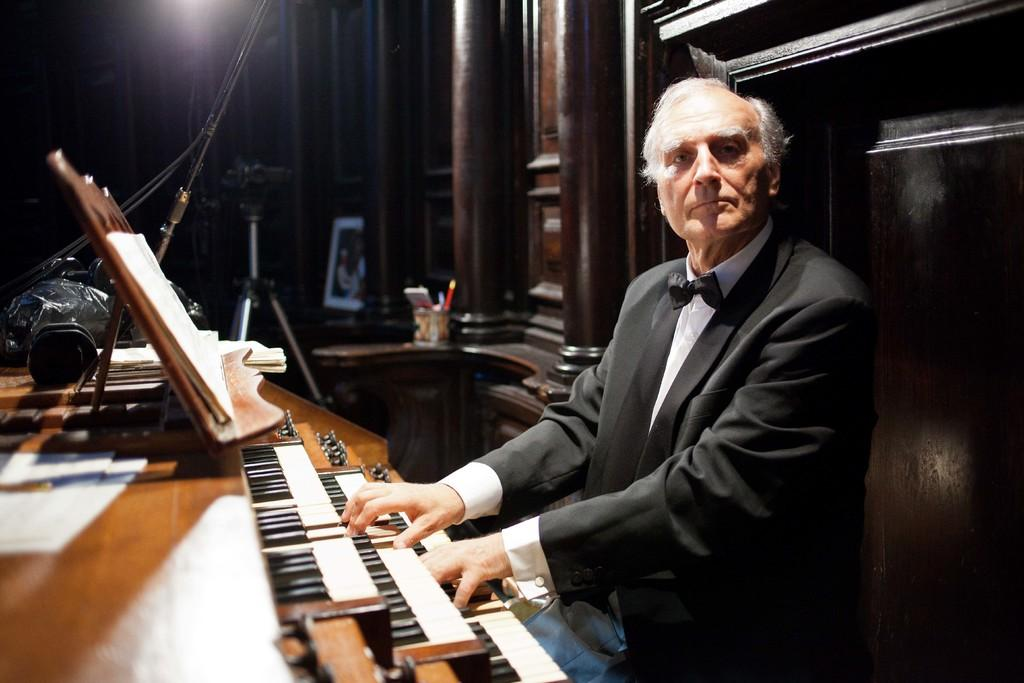Who is the main subject in the image? There is an old man in the image. What is the old man doing in the image? The old man is playing a piano. Where is the piano located in relation to the old man? The piano is in front of the old man. What other object can be seen in the image? There is a camera with a stand in the image. What type of station does the old man use to play the piano in the image? The image does not show any specific type of station for playing the piano; the old man is simply playing the piano in front of him. 